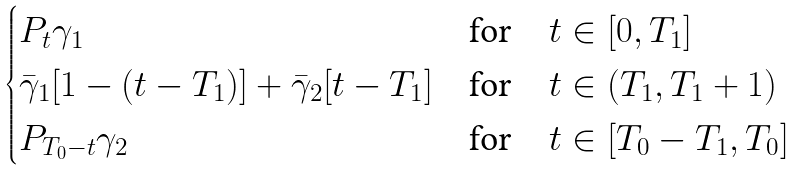<formula> <loc_0><loc_0><loc_500><loc_500>\begin{cases} P _ { t } \gamma _ { 1 } & \text {for} \quad t \in [ 0 , T _ { 1 } ] \\ \bar { \gamma } _ { 1 } [ 1 - ( t - T _ { 1 } ) ] + \bar { \gamma } _ { 2 } [ t - T _ { 1 } ] & \text {for} \quad t \in ( T _ { 1 } , T _ { 1 } + 1 ) \\ P _ { T _ { 0 } - t } \gamma _ { 2 } & \text {for} \quad t \in [ T _ { 0 } - T _ { 1 } , T _ { 0 } ] \end{cases}</formula> 